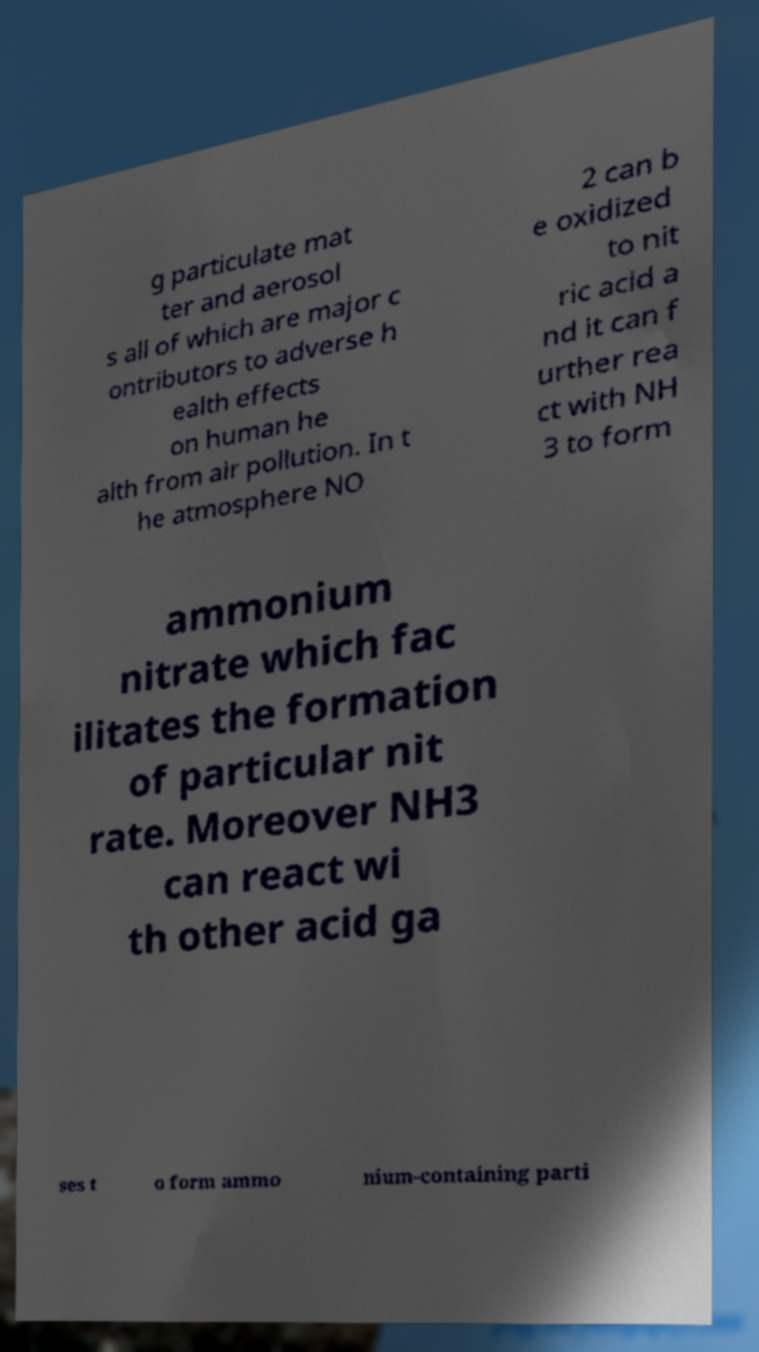Could you extract and type out the text from this image? g particulate mat ter and aerosol s all of which are major c ontributors to adverse h ealth effects on human he alth from air pollution. In t he atmosphere NO 2 can b e oxidized to nit ric acid a nd it can f urther rea ct with NH 3 to form ammonium nitrate which fac ilitates the formation of particular nit rate. Moreover NH3 can react wi th other acid ga ses t o form ammo nium-containing parti 